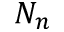Convert formula to latex. <formula><loc_0><loc_0><loc_500><loc_500>N _ { n }</formula> 